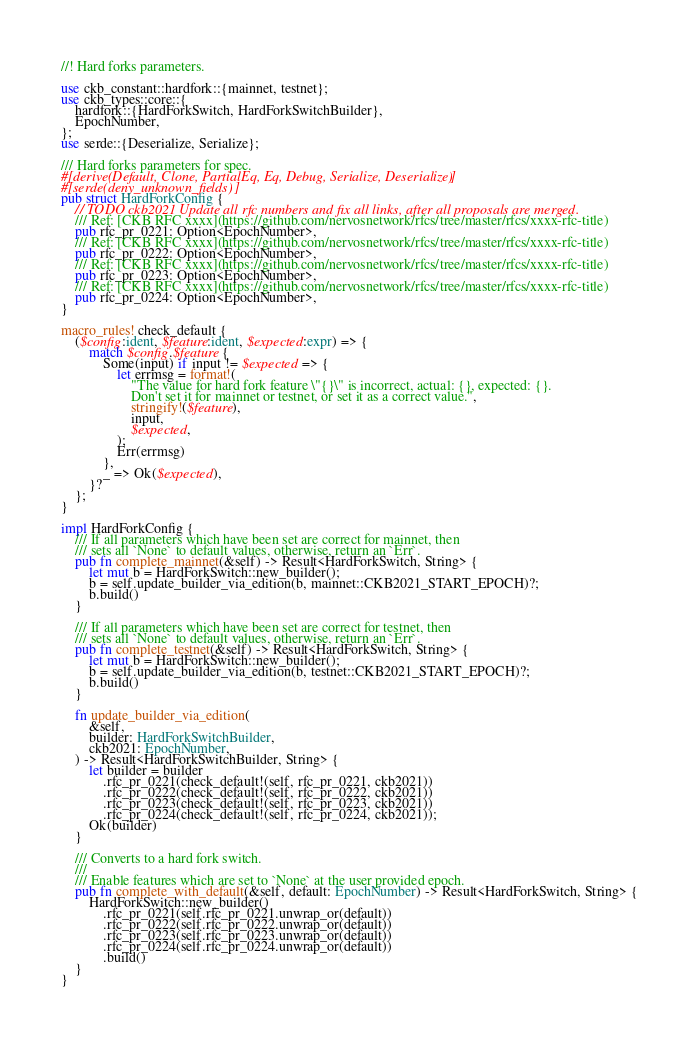<code> <loc_0><loc_0><loc_500><loc_500><_Rust_>//! Hard forks parameters.

use ckb_constant::hardfork::{mainnet, testnet};
use ckb_types::core::{
    hardfork::{HardForkSwitch, HardForkSwitchBuilder},
    EpochNumber,
};
use serde::{Deserialize, Serialize};

/// Hard forks parameters for spec.
#[derive(Default, Clone, PartialEq, Eq, Debug, Serialize, Deserialize)]
#[serde(deny_unknown_fields)]
pub struct HardForkConfig {
    // TODO ckb2021 Update all rfc numbers and fix all links, after all proposals are merged.
    /// Ref: [CKB RFC xxxx](https://github.com/nervosnetwork/rfcs/tree/master/rfcs/xxxx-rfc-title)
    pub rfc_pr_0221: Option<EpochNumber>,
    /// Ref: [CKB RFC xxxx](https://github.com/nervosnetwork/rfcs/tree/master/rfcs/xxxx-rfc-title)
    pub rfc_pr_0222: Option<EpochNumber>,
    /// Ref: [CKB RFC xxxx](https://github.com/nervosnetwork/rfcs/tree/master/rfcs/xxxx-rfc-title)
    pub rfc_pr_0223: Option<EpochNumber>,
    /// Ref: [CKB RFC xxxx](https://github.com/nervosnetwork/rfcs/tree/master/rfcs/xxxx-rfc-title)
    pub rfc_pr_0224: Option<EpochNumber>,
}

macro_rules! check_default {
    ($config:ident, $feature:ident, $expected:expr) => {
        match $config.$feature {
            Some(input) if input != $expected => {
                let errmsg = format!(
                    "The value for hard fork feature \"{}\" is incorrect, actual: {}, expected: {}.
                    Don't set it for mainnet or testnet, or set it as a correct value.",
                    stringify!($feature),
                    input,
                    $expected,
                );
                Err(errmsg)
            },
            _ => Ok($expected),
        }?
    };
}

impl HardForkConfig {
    /// If all parameters which have been set are correct for mainnet, then
    /// sets all `None` to default values, otherwise, return an `Err`.
    pub fn complete_mainnet(&self) -> Result<HardForkSwitch, String> {
        let mut b = HardForkSwitch::new_builder();
        b = self.update_builder_via_edition(b, mainnet::CKB2021_START_EPOCH)?;
        b.build()
    }

    /// If all parameters which have been set are correct for testnet, then
    /// sets all `None` to default values, otherwise, return an `Err`.
    pub fn complete_testnet(&self) -> Result<HardForkSwitch, String> {
        let mut b = HardForkSwitch::new_builder();
        b = self.update_builder_via_edition(b, testnet::CKB2021_START_EPOCH)?;
        b.build()
    }

    fn update_builder_via_edition(
        &self,
        builder: HardForkSwitchBuilder,
        ckb2021: EpochNumber,
    ) -> Result<HardForkSwitchBuilder, String> {
        let builder = builder
            .rfc_pr_0221(check_default!(self, rfc_pr_0221, ckb2021))
            .rfc_pr_0222(check_default!(self, rfc_pr_0222, ckb2021))
            .rfc_pr_0223(check_default!(self, rfc_pr_0223, ckb2021))
            .rfc_pr_0224(check_default!(self, rfc_pr_0224, ckb2021));
        Ok(builder)
    }

    /// Converts to a hard fork switch.
    ///
    /// Enable features which are set to `None` at the user provided epoch.
    pub fn complete_with_default(&self, default: EpochNumber) -> Result<HardForkSwitch, String> {
        HardForkSwitch::new_builder()
            .rfc_pr_0221(self.rfc_pr_0221.unwrap_or(default))
            .rfc_pr_0222(self.rfc_pr_0222.unwrap_or(default))
            .rfc_pr_0223(self.rfc_pr_0223.unwrap_or(default))
            .rfc_pr_0224(self.rfc_pr_0224.unwrap_or(default))
            .build()
    }
}
</code> 